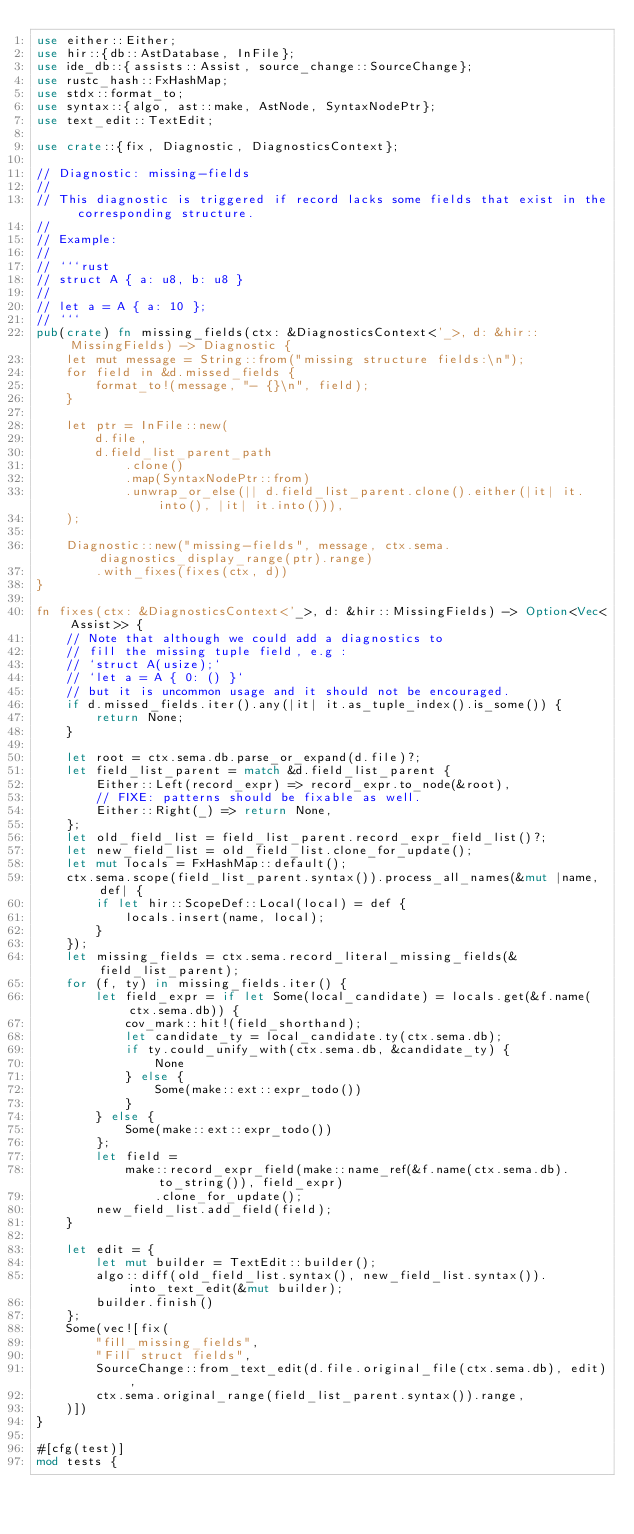<code> <loc_0><loc_0><loc_500><loc_500><_Rust_>use either::Either;
use hir::{db::AstDatabase, InFile};
use ide_db::{assists::Assist, source_change::SourceChange};
use rustc_hash::FxHashMap;
use stdx::format_to;
use syntax::{algo, ast::make, AstNode, SyntaxNodePtr};
use text_edit::TextEdit;

use crate::{fix, Diagnostic, DiagnosticsContext};

// Diagnostic: missing-fields
//
// This diagnostic is triggered if record lacks some fields that exist in the corresponding structure.
//
// Example:
//
// ```rust
// struct A { a: u8, b: u8 }
//
// let a = A { a: 10 };
// ```
pub(crate) fn missing_fields(ctx: &DiagnosticsContext<'_>, d: &hir::MissingFields) -> Diagnostic {
    let mut message = String::from("missing structure fields:\n");
    for field in &d.missed_fields {
        format_to!(message, "- {}\n", field);
    }

    let ptr = InFile::new(
        d.file,
        d.field_list_parent_path
            .clone()
            .map(SyntaxNodePtr::from)
            .unwrap_or_else(|| d.field_list_parent.clone().either(|it| it.into(), |it| it.into())),
    );

    Diagnostic::new("missing-fields", message, ctx.sema.diagnostics_display_range(ptr).range)
        .with_fixes(fixes(ctx, d))
}

fn fixes(ctx: &DiagnosticsContext<'_>, d: &hir::MissingFields) -> Option<Vec<Assist>> {
    // Note that although we could add a diagnostics to
    // fill the missing tuple field, e.g :
    // `struct A(usize);`
    // `let a = A { 0: () }`
    // but it is uncommon usage and it should not be encouraged.
    if d.missed_fields.iter().any(|it| it.as_tuple_index().is_some()) {
        return None;
    }

    let root = ctx.sema.db.parse_or_expand(d.file)?;
    let field_list_parent = match &d.field_list_parent {
        Either::Left(record_expr) => record_expr.to_node(&root),
        // FIXE: patterns should be fixable as well.
        Either::Right(_) => return None,
    };
    let old_field_list = field_list_parent.record_expr_field_list()?;
    let new_field_list = old_field_list.clone_for_update();
    let mut locals = FxHashMap::default();
    ctx.sema.scope(field_list_parent.syntax()).process_all_names(&mut |name, def| {
        if let hir::ScopeDef::Local(local) = def {
            locals.insert(name, local);
        }
    });
    let missing_fields = ctx.sema.record_literal_missing_fields(&field_list_parent);
    for (f, ty) in missing_fields.iter() {
        let field_expr = if let Some(local_candidate) = locals.get(&f.name(ctx.sema.db)) {
            cov_mark::hit!(field_shorthand);
            let candidate_ty = local_candidate.ty(ctx.sema.db);
            if ty.could_unify_with(ctx.sema.db, &candidate_ty) {
                None
            } else {
                Some(make::ext::expr_todo())
            }
        } else {
            Some(make::ext::expr_todo())
        };
        let field =
            make::record_expr_field(make::name_ref(&f.name(ctx.sema.db).to_string()), field_expr)
                .clone_for_update();
        new_field_list.add_field(field);
    }

    let edit = {
        let mut builder = TextEdit::builder();
        algo::diff(old_field_list.syntax(), new_field_list.syntax()).into_text_edit(&mut builder);
        builder.finish()
    };
    Some(vec![fix(
        "fill_missing_fields",
        "Fill struct fields",
        SourceChange::from_text_edit(d.file.original_file(ctx.sema.db), edit),
        ctx.sema.original_range(field_list_parent.syntax()).range,
    )])
}

#[cfg(test)]
mod tests {</code> 